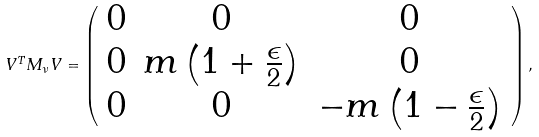Convert formula to latex. <formula><loc_0><loc_0><loc_500><loc_500>V ^ { T } M _ { \nu } V = \left ( \begin{array} { c c c } 0 & 0 & 0 \\ 0 & m \left ( 1 + \frac { \epsilon } { 2 } \right ) & 0 \\ 0 & 0 & - m \left ( 1 - \frac { \epsilon } { 2 } \right ) \end{array} \right ) ,</formula> 